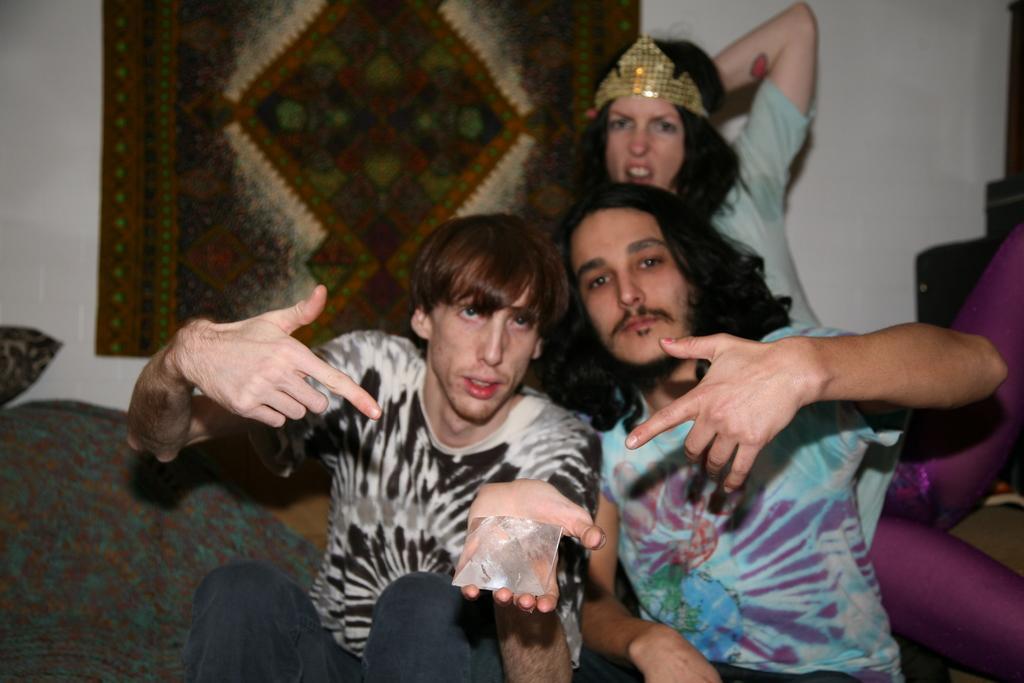Please provide a concise description of this image. Here we can see three persons are posing to a camera. There are pillows. In the background we can see wall and cloth. 